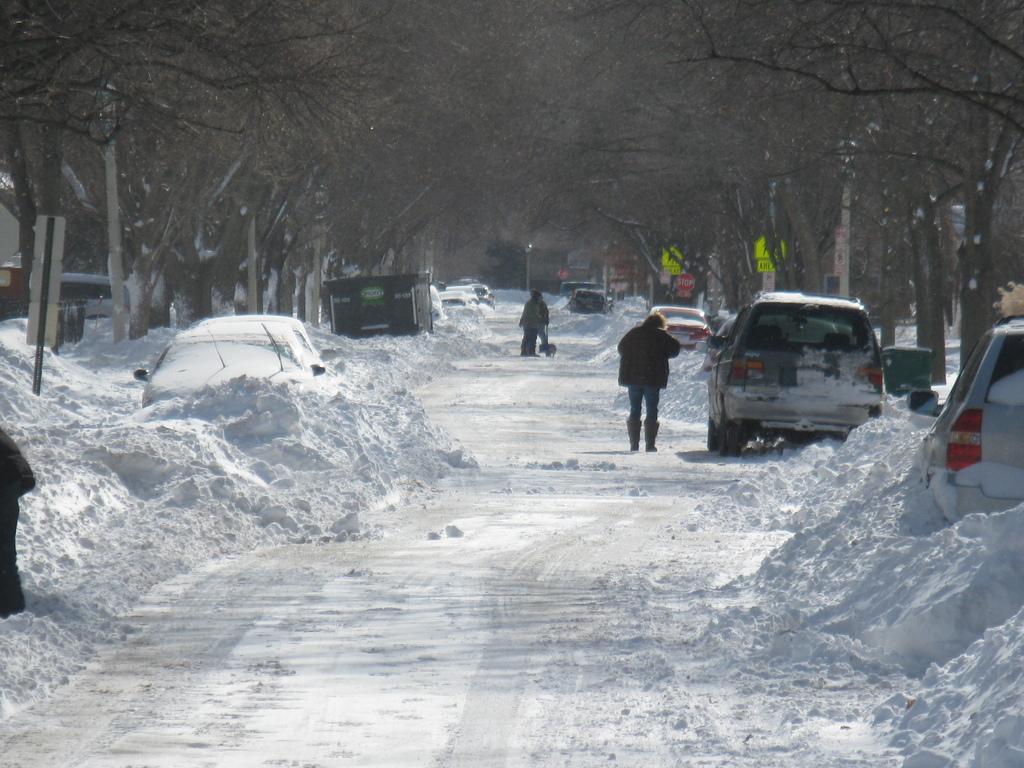Describe this image in one or two sentences. This picture is clicked outside. In the center we can see the group of vehicles seems to be parked on the ground and we can see the group of persons and there is a slot of snow. In the background we can see the trees, houses and some other objects. 